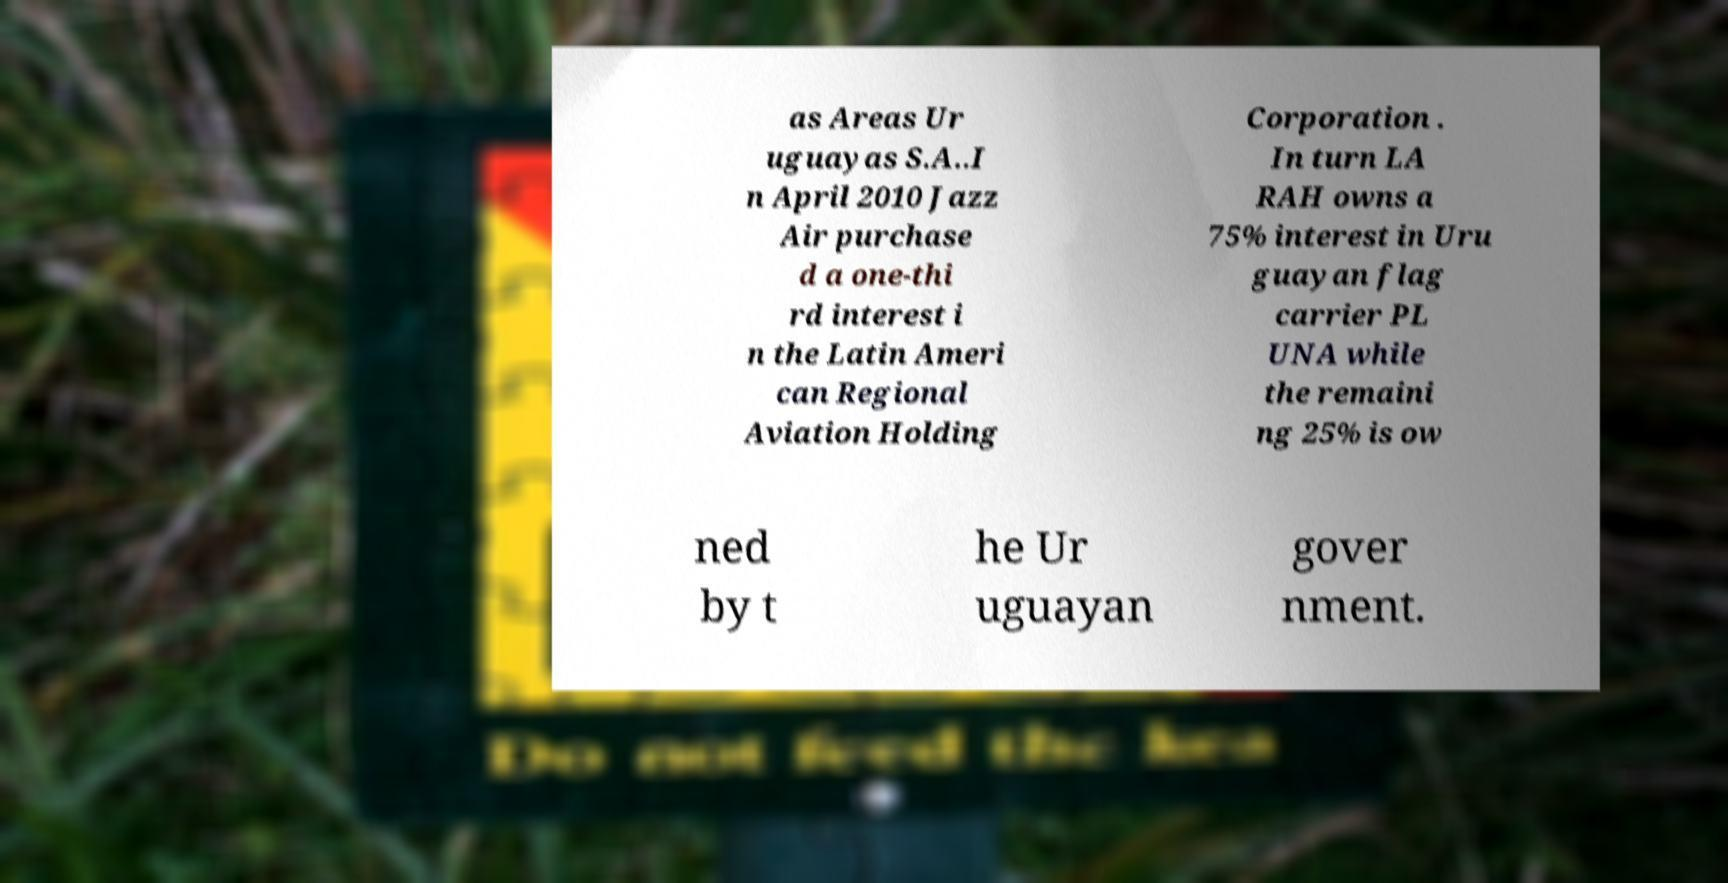I need the written content from this picture converted into text. Can you do that? as Areas Ur uguayas S.A..I n April 2010 Jazz Air purchase d a one-thi rd interest i n the Latin Ameri can Regional Aviation Holding Corporation . In turn LA RAH owns a 75% interest in Uru guayan flag carrier PL UNA while the remaini ng 25% is ow ned by t he Ur uguayan gover nment. 